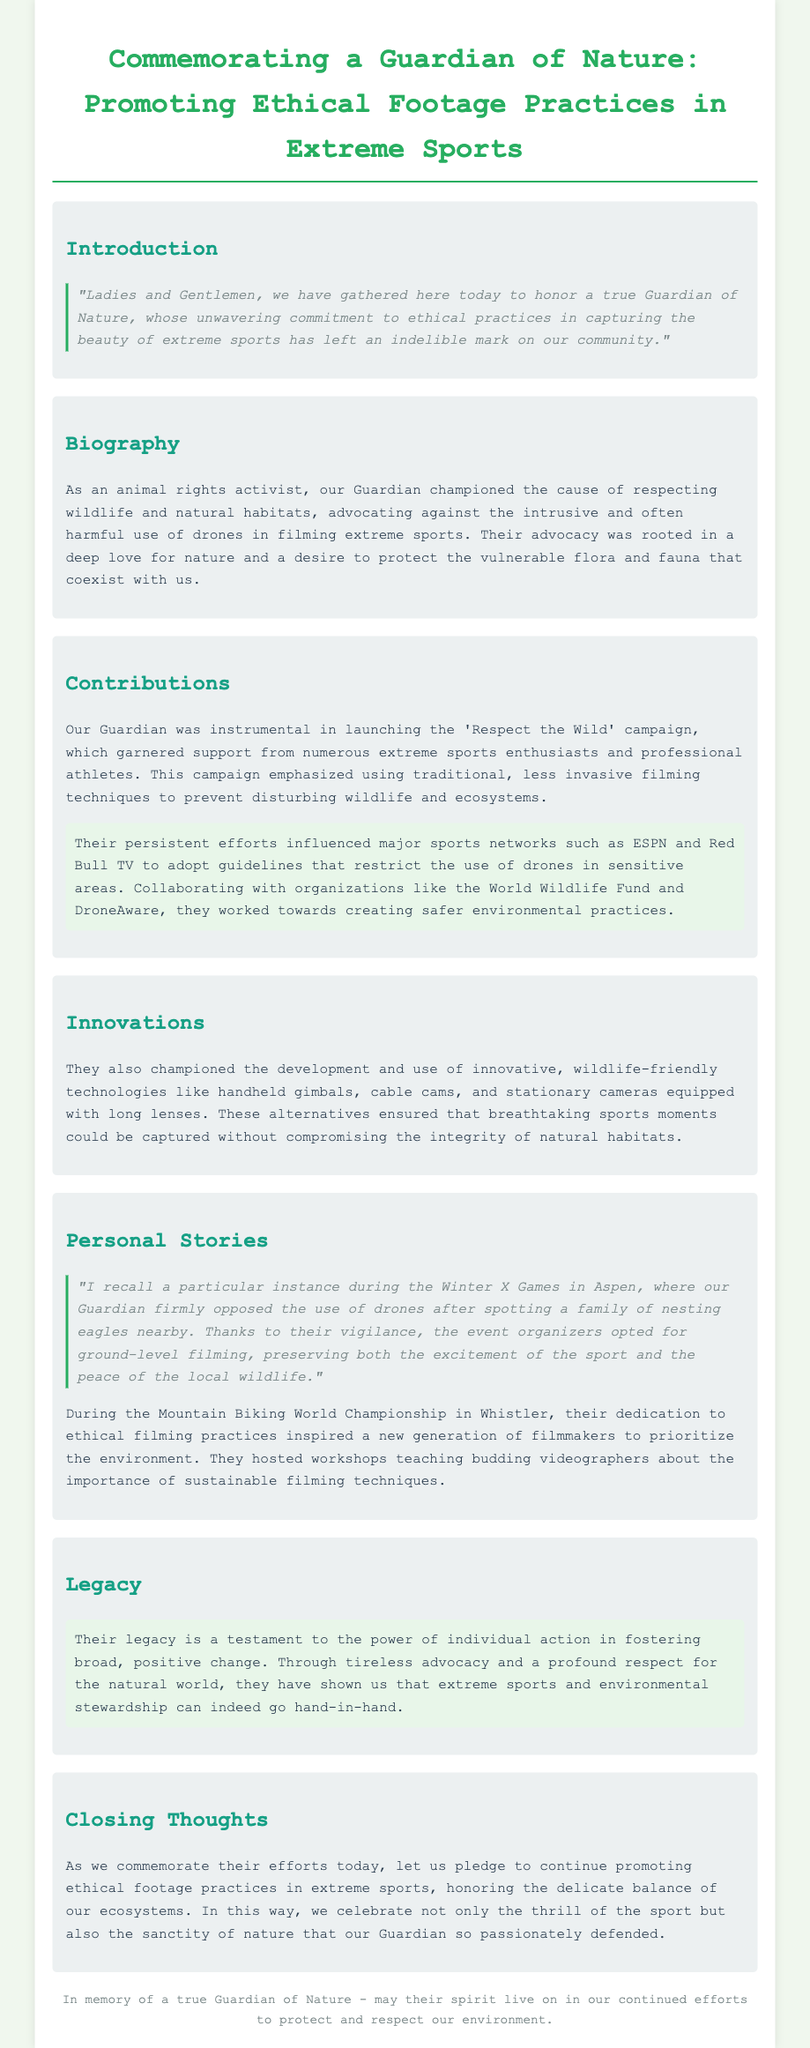What campaign did the Guardian launch? The document mentions the 'Respect the Wild' campaign that the Guardian was instrumental in launching.
Answer: Respect the Wild What technology alternatives did the Guardian promote for filming? The document lists alternatives such as handheld gimbals, cable cams, and stationary cameras with long lenses.
Answer: Handheld gimbals Where did the Guardian oppose the use of drones? The document describes a specific instance during the Winter X Games in Aspen where the Guardian opposed drone use.
Answer: Winter X Games in Aspen Which organizations did the Guardian collaborate with? The document specifically mentions collaborations with the World Wildlife Fund and DroneAware.
Answer: World Wildlife Fund, DroneAware What impact did the Guardian have on major sports networks? The document states that their efforts influenced sports networks like ESPN and Red Bull TV to adopt drone use guidelines.
Answer: Adopt guidelines How did the Guardian influence new filmmakers? The document indicates that their dedication inspired new filmmakers to prioritize the environment through workshops.
Answer: Workshops What was the theme of the closing thoughts? The closing thoughts emphasize promoting ethical footage practices in extreme sports while respecting ecosystems.
Answer: Ethical footage practices In what year did the Guardian advocate for ethical filming at an event? The specific event mentioned in the document is during the Winter X Games, with no year provided, but it's implied to be contemporary to their advocacy.
Answer: (No specific year given) What was the Guardian's view on the relationship between extreme sports and the environment? The document highlights that they believed extreme sports and environmental stewardship can go hand-in-hand.
Answer: Go hand-in-hand 